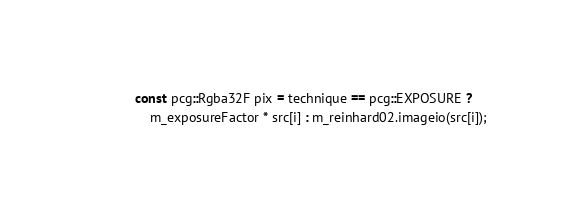<code> <loc_0><loc_0><loc_500><loc_500><_C++_>            const pcg::Rgba32F pix = technique == pcg::EXPOSURE ?
                m_exposureFactor * src[i] : m_reinhard02.imageio(src[i]);</code> 